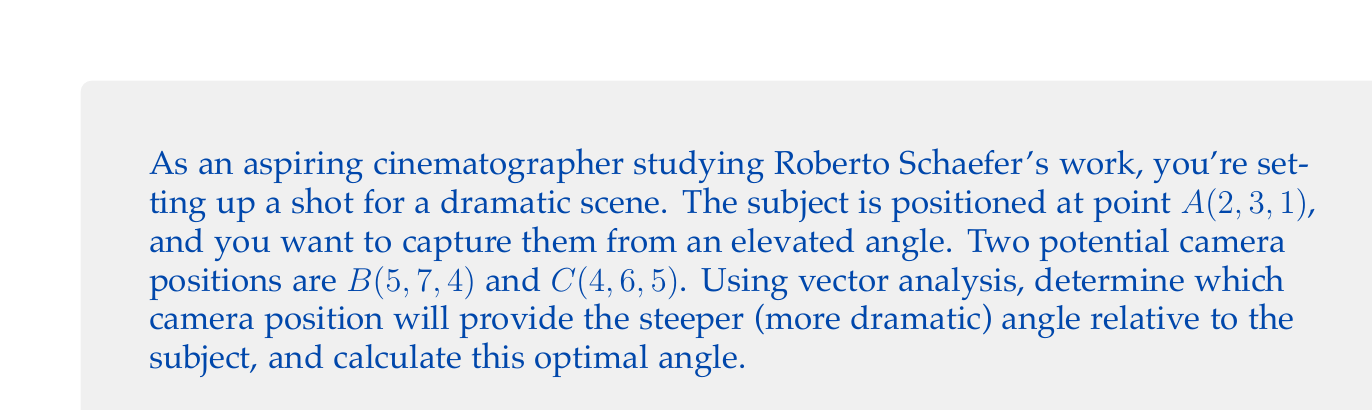Solve this math problem. To solve this problem, we'll use vector analysis to determine the angle between the vertical axis and the line from the subject to each camera position. The steeper angle will be the optimal one for a more dramatic shot.

Step 1: Define vectors from the subject to each camera position.
$\vec{AB} = B - A = (5-2, 7-3, 4-1) = (3, 4, 3)$
$\vec{AC} = C - A = (4-2, 6-3, 5-1) = (2, 3, 4)$

Step 2: Define the vertical vector.
$\vec{v} = (0, 0, 1)$

Step 3: Calculate the angle between each vector and the vertical using the dot product formula:
$$\cos \theta = \frac{\vec{a} \cdot \vec{b}}{|\vec{a}||\vec{b}|}$$

For $\vec{AB}$:
$$\cos \theta_{AB} = \frac{(3, 4, 3) \cdot (0, 0, 1)}{\sqrt{3^2 + 4^2 + 3^2}\sqrt{1}} = \frac{3}{\sqrt{34}}$$
$$\theta_{AB} = \arccos(\frac{3}{\sqrt{34}}) \approx 0.8701 \text{ radians} \approx 49.84°$$

For $\vec{AC}$:
$$\cos \theta_{AC} = \frac{(2, 3, 4) \cdot (0, 0, 1)}{\sqrt{2^2 + 3^2 + 4^2}\sqrt{1}} = \frac{4}{\sqrt{29}}$$
$$\theta_{AC} = \arccos(\frac{4}{\sqrt{29}}) \approx 0.6435 \text{ radians} \approx 36.87°$$

Step 4: Compare the angles. The steeper angle (closer to 0°) will be the more dramatic shot.

[asy]
import geometry;

size(200);
draw((0,0)--(5,5), arrow=Arrow(TeXHead));
draw((0,0)--(4,6), arrow=Arrow(TeXHead));
draw((0,0)--(0,7), arrow=Arrow(TeXHead));

label("A (Subject)", (0,0), SW);
label("B", (5,5), NE);
label("C", (4,6), NW);
label("Vertical", (0,7), N);

draw(arc((0,0),1,0,49.84), blue);
draw(arc((0,0),1.2,0,36.87), red);

label("49.84°", (0.8,0.6), blue);
label("36.87°", (1,0.4), red);
[/asy]
Answer: The optimal camera position for a more dramatic shot is $B(5, 7, 4)$, which provides a steeper angle of approximately 49.84° relative to the vertical axis. 